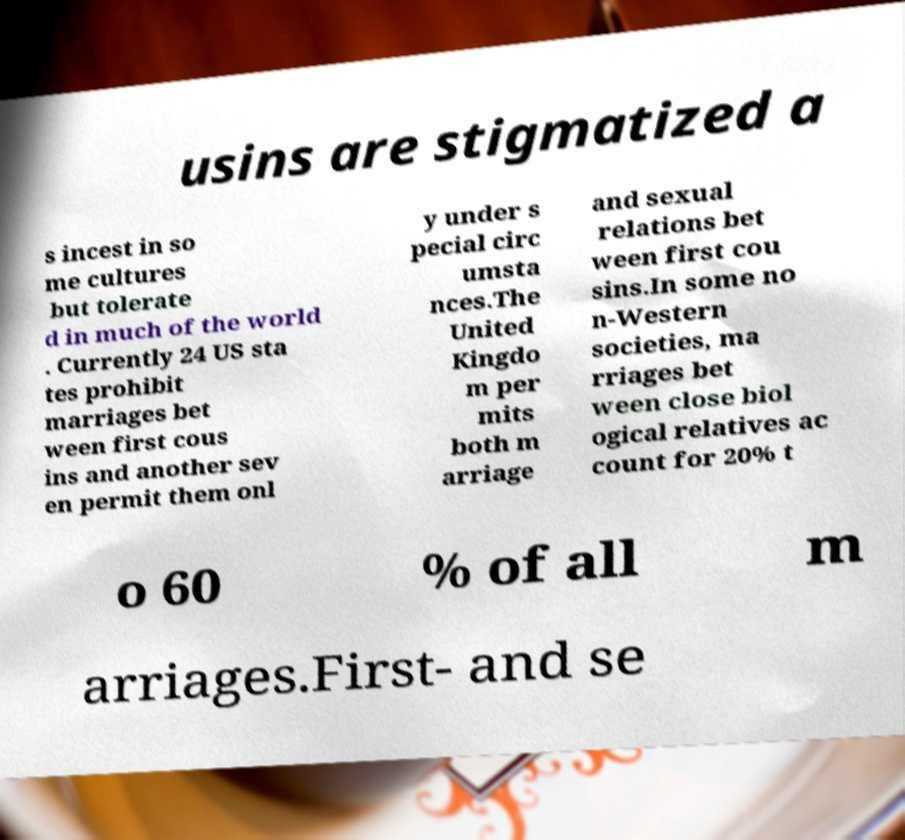Please identify and transcribe the text found in this image. usins are stigmatized a s incest in so me cultures but tolerate d in much of the world . Currently 24 US sta tes prohibit marriages bet ween first cous ins and another sev en permit them onl y under s pecial circ umsta nces.The United Kingdo m per mits both m arriage and sexual relations bet ween first cou sins.In some no n-Western societies, ma rriages bet ween close biol ogical relatives ac count for 20% t o 60 % of all m arriages.First- and se 